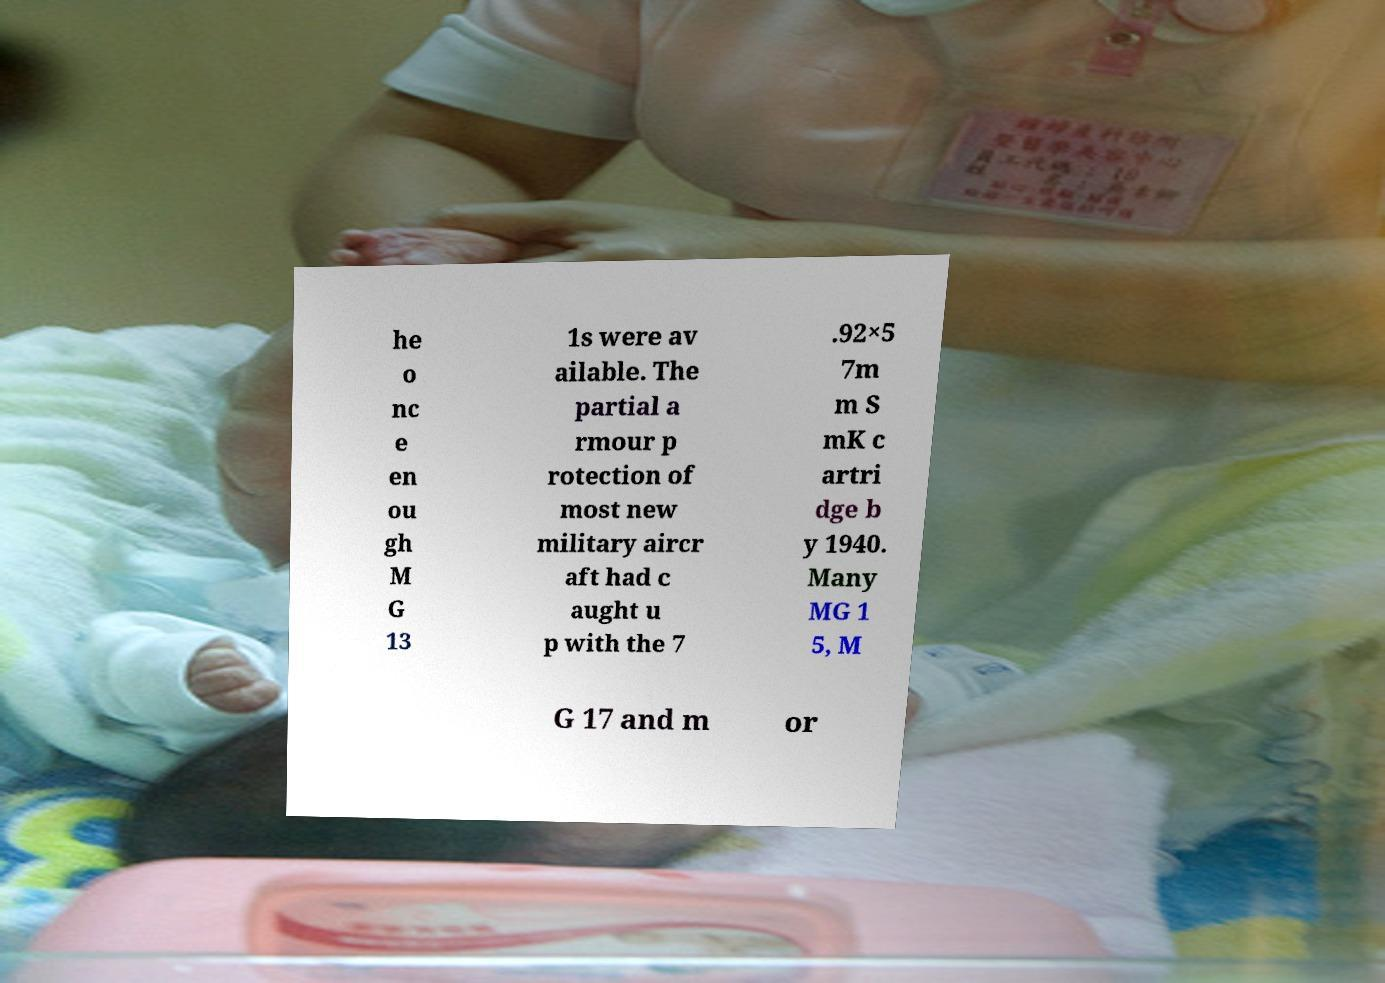Can you accurately transcribe the text from the provided image for me? he o nc e en ou gh M G 13 1s were av ailable. The partial a rmour p rotection of most new military aircr aft had c aught u p with the 7 .92×5 7m m S mK c artri dge b y 1940. Many MG 1 5, M G 17 and m or 